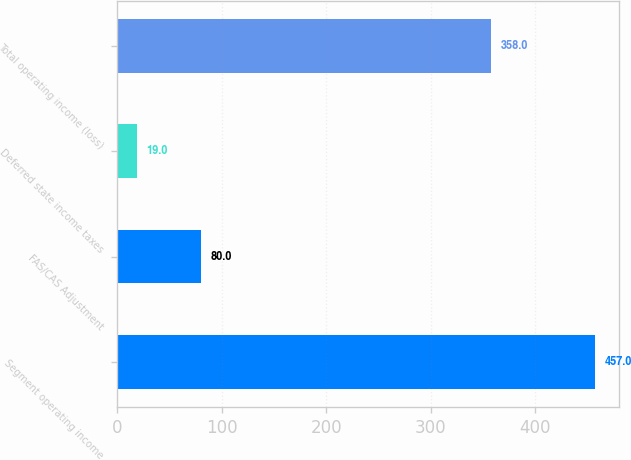Convert chart to OTSL. <chart><loc_0><loc_0><loc_500><loc_500><bar_chart><fcel>Segment operating income<fcel>FAS/CAS Adjustment<fcel>Deferred state income taxes<fcel>Total operating income (loss)<nl><fcel>457<fcel>80<fcel>19<fcel>358<nl></chart> 